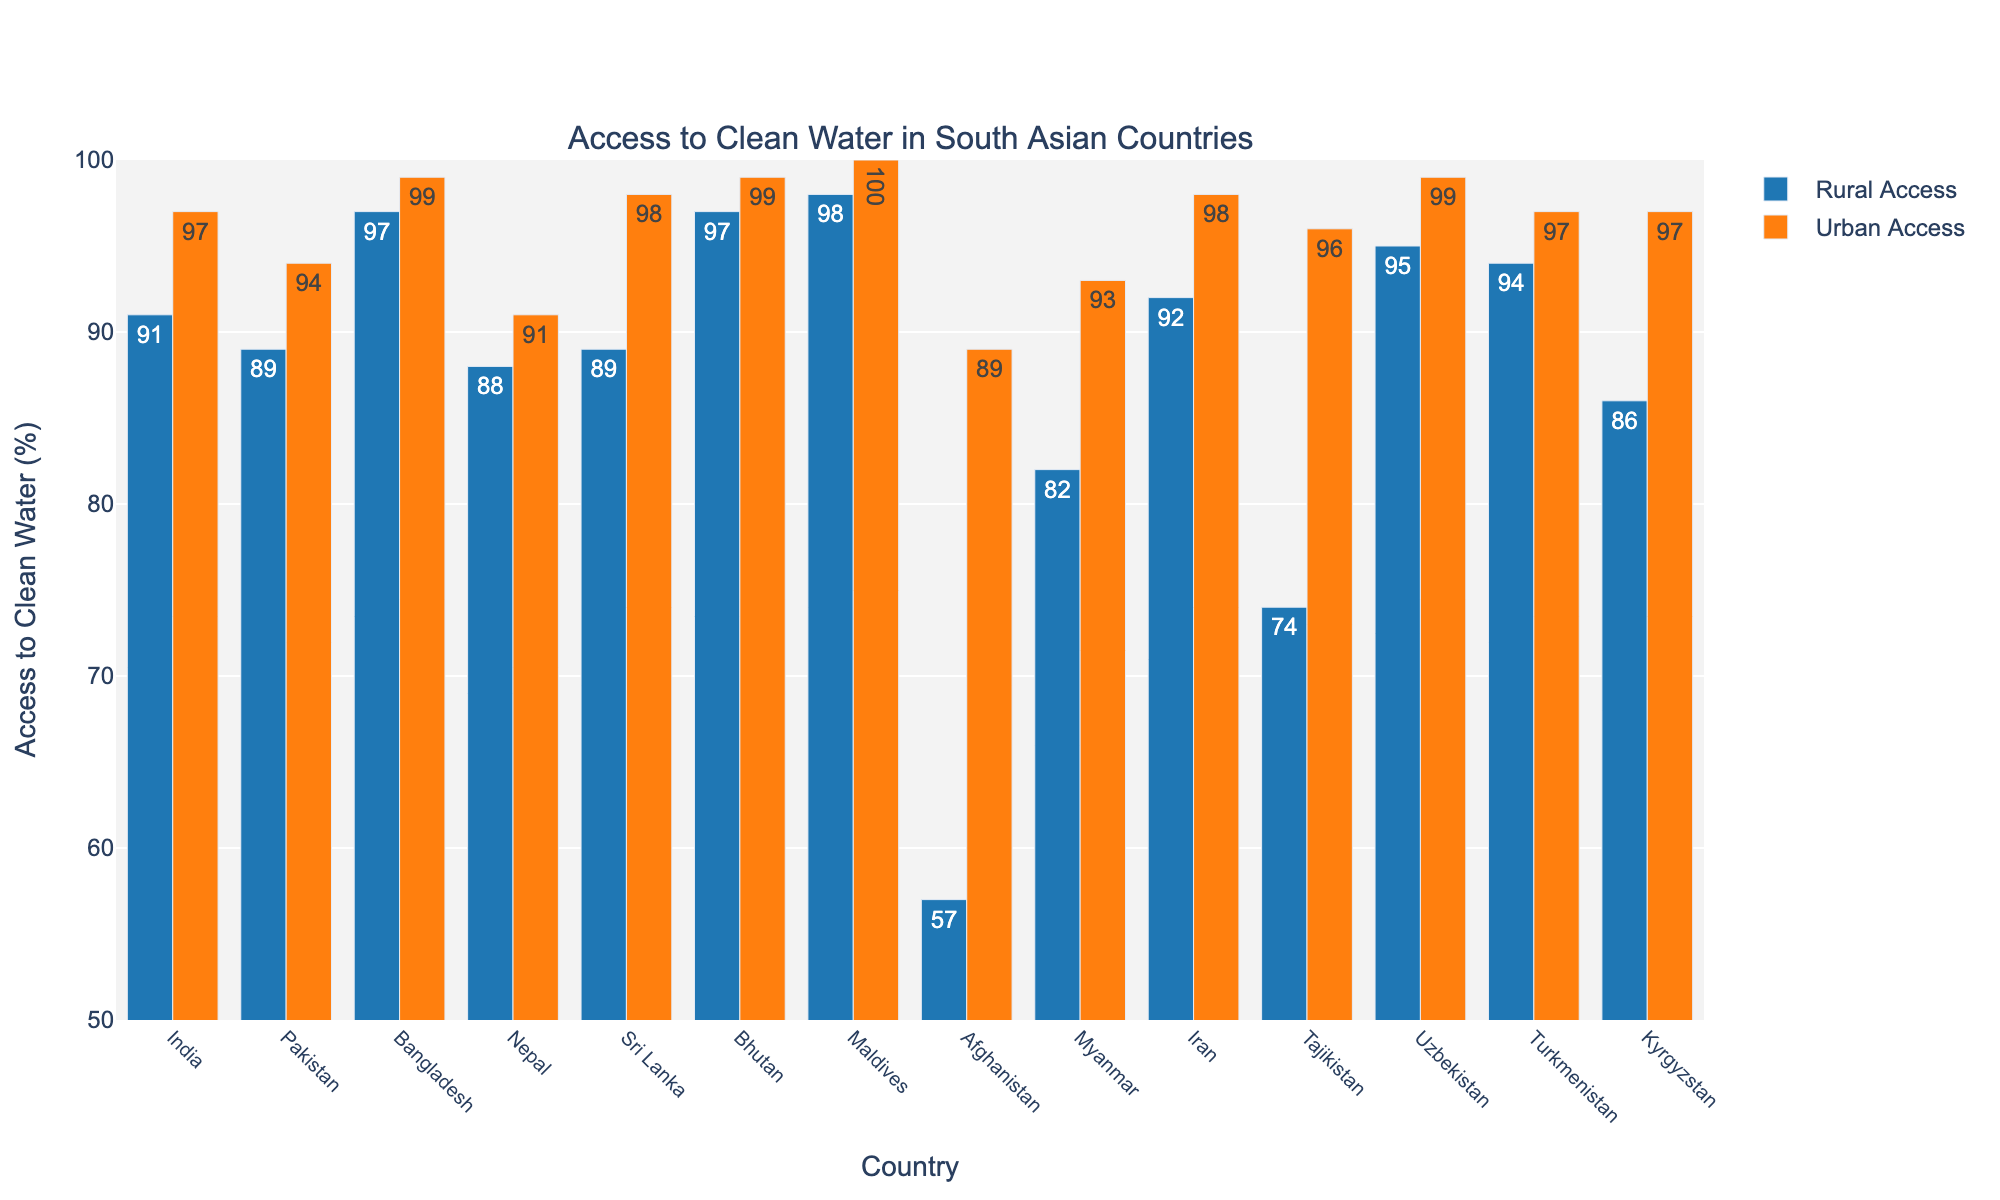Which country has the highest percentage of rural access to clean water? The highest percentage for rural access to clean water can be found by looking for the tallest blue bar in the chart.
Answer: Maldives What is the difference in urban access to clean water between Afghanistan and India? The urban access for Afghanistan is 89%, and for India, it is 97%. Subtract Afghanistan's percentage from India's. 97% - 89% = 8%
Answer: 8% Which country shows the largest discrepancy between rural and urban access to clean water? To find the largest discrepancy, we need to find the country with the biggest difference between the height of the blue and orange bars. The difference is highest for Afghanistan (89% - 57% = 32%).
Answer: Afghanistan Is there any country where the rural access to clean water is greater than the urban access? By comparing the blue and orange bars for each country, we see that there is no instance where the blue bar (rural) is taller than the orange bar (urban).
Answer: No Which countries have an urban access rate of 99% or higher? By checking the orange bars for urban access rates of 99% or above, we identify Bangladesh, Bhutan, Maldives, Uzbekistan, and Iran.
Answer: Bangladesh, Bhutan, Maldives, Uzbekistan, Iran What is the average rural access to clean water across all countries? Add all rural access percentages (91+89+97+88+89+97+98+57+82+92+74+95+94+86) and divide it by the number of countries (14). The sum is 1229%, and the average is 1229/14 ≈ 87.79%.
Answer: 87.79% How does the urban access rate in Bangladesh compare to that in Sri Lanka? The urban access rate in Bangladesh is 99%, while in Sri Lanka it is 98%. Comparing these values shows that Bangladesh has a 1% higher urban access rate than Sri Lanka.
Answer: Bangladesh is higher Which country on the list has the lowest rural access to clean water? The country with the lowest rural access is identified by the shortest blue bar. Afghanistan has the lowest rural access at 57%.
Answer: Afghanistan Among the countries listed, how many have a rural access rate of at least 90%? Count the countries with rural access percentages of 90% or higher by checking the blue bars. These countries are India, Bangladesh, Bhutan, Iran, Uzbekistan, Turkmenistan, and Maldives—a total of 7 countries.
Answer: 7 What is the combined urban access percentage for the Maldives and Bhutan? Add the urban access percentages for Maldives (100%) and Bhutan (99%). 100% + 99% = 199%.
Answer: 199% 